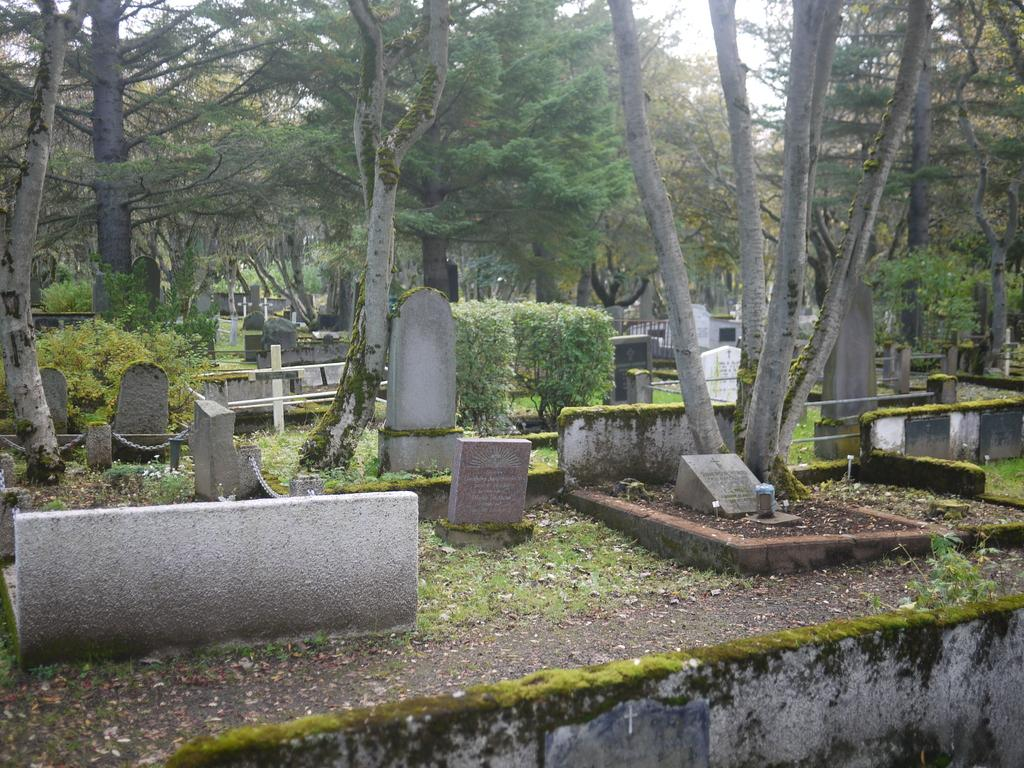Where was the image taken? The image was taken in a graveyard. What can be seen among the graves in the image? There are headstones in the image. What type of vegetation is present in the image? There are trees in the image. What additional feature can be found in the graveyard? There is a garden in the image. What is visible above the graveyard? The sky is visible in the image. What type of boat can be seen sailing in the garden in the image? There is no boat present in the image, as it is taken in a graveyard with a garden, not a body of water. 